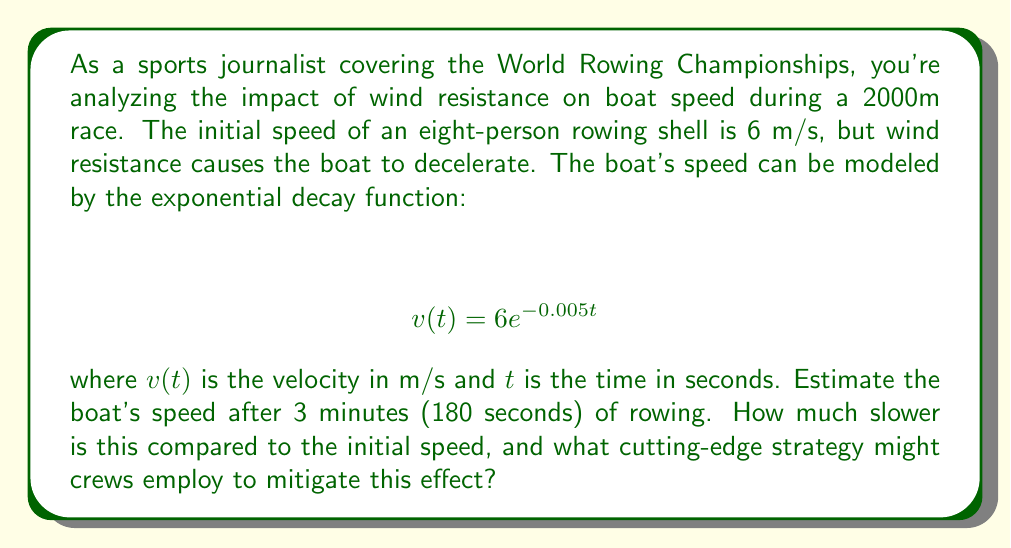What is the answer to this math problem? To solve this problem, we'll follow these steps:

1) Use the given exponential decay function to calculate the boat's speed after 180 seconds:

   $$ v(180) = 6e^{-0.005(180)} $$

2) Simplify the exponent:
   
   $$ v(180) = 6e^{-0.9} $$

3) Calculate the result:
   
   $$ v(180) = 6 \cdot 0.4066 \approx 2.44 \text{ m/s} $$

4) Calculate the difference between the initial speed and the speed after 3 minutes:
   
   $$ \text{Speed difference} = 6 - 2.44 = 3.56 \text{ m/s} $$

5) Calculate the percentage decrease:
   
   $$ \text{Percentage decrease} = \frac{3.56}{6} \cdot 100\% \approx 59.3\% $$

The exponential decay model shows a significant decrease in speed due to wind resistance. To mitigate this effect, crews might employ strategies such as:

- Optimizing boat design for reduced drag
- Improving rowing technique to maintain speed
- Using advanced materials in boat construction
- Implementing precise pacing strategies to conserve energy

These strategies could provide a competitive edge in this grueling sport where every second counts.
Answer: The boat's speed after 3 minutes is approximately 2.44 m/s, which is 3.56 m/s or 59.3% slower than the initial speed of 6 m/s. 